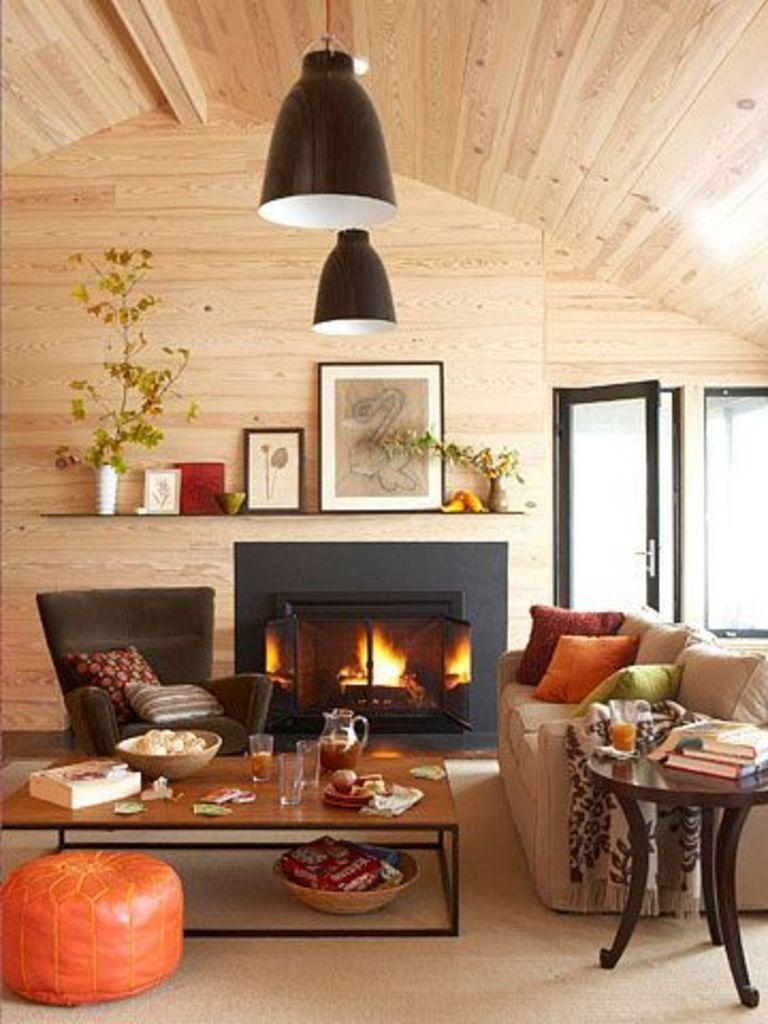What type of living organisms can be seen in the image? Plants are visible in the image. What type of decorative items can be seen in the image? There are photo frames in the image. What type of furniture is present in the image? There is a sofa set in the image. How many tables are visible in the image? There are two tables in the image. What is placed on the tables? There are items on the tables. What architectural feature is present in the image? There is a window in the image. What type of soft furnishings are present in the image? There are pillows in the image. Can you tell me how many hydrants are visible in the image? There are no hydrants present in the image. What type of road is visible in the image? There is no road visible in the image. 